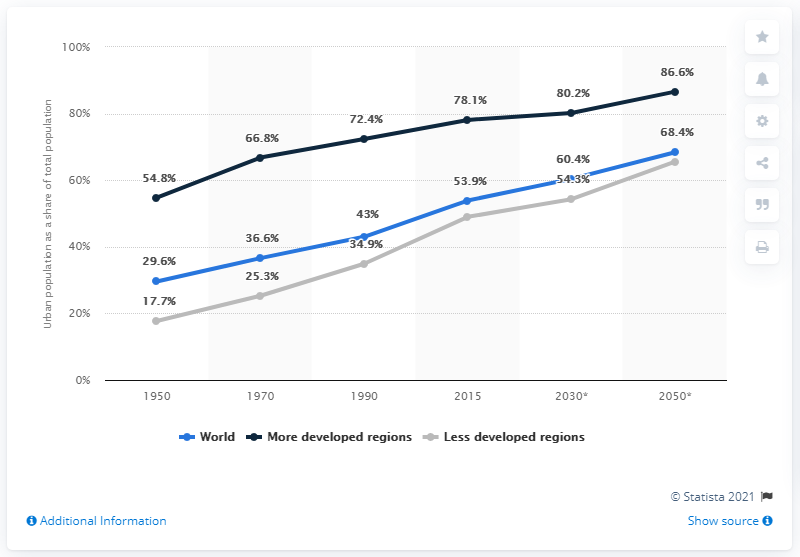Give some essential details in this illustration. By 2050, it is projected that 86.6% of the global population will live in urban areas. 